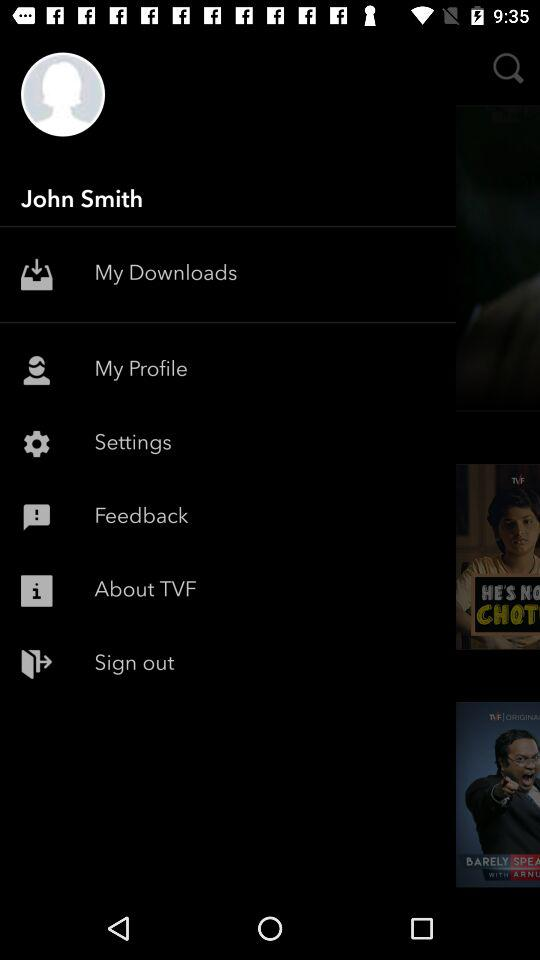How old is the user?
When the provided information is insufficient, respond with <no answer>. <no answer> 